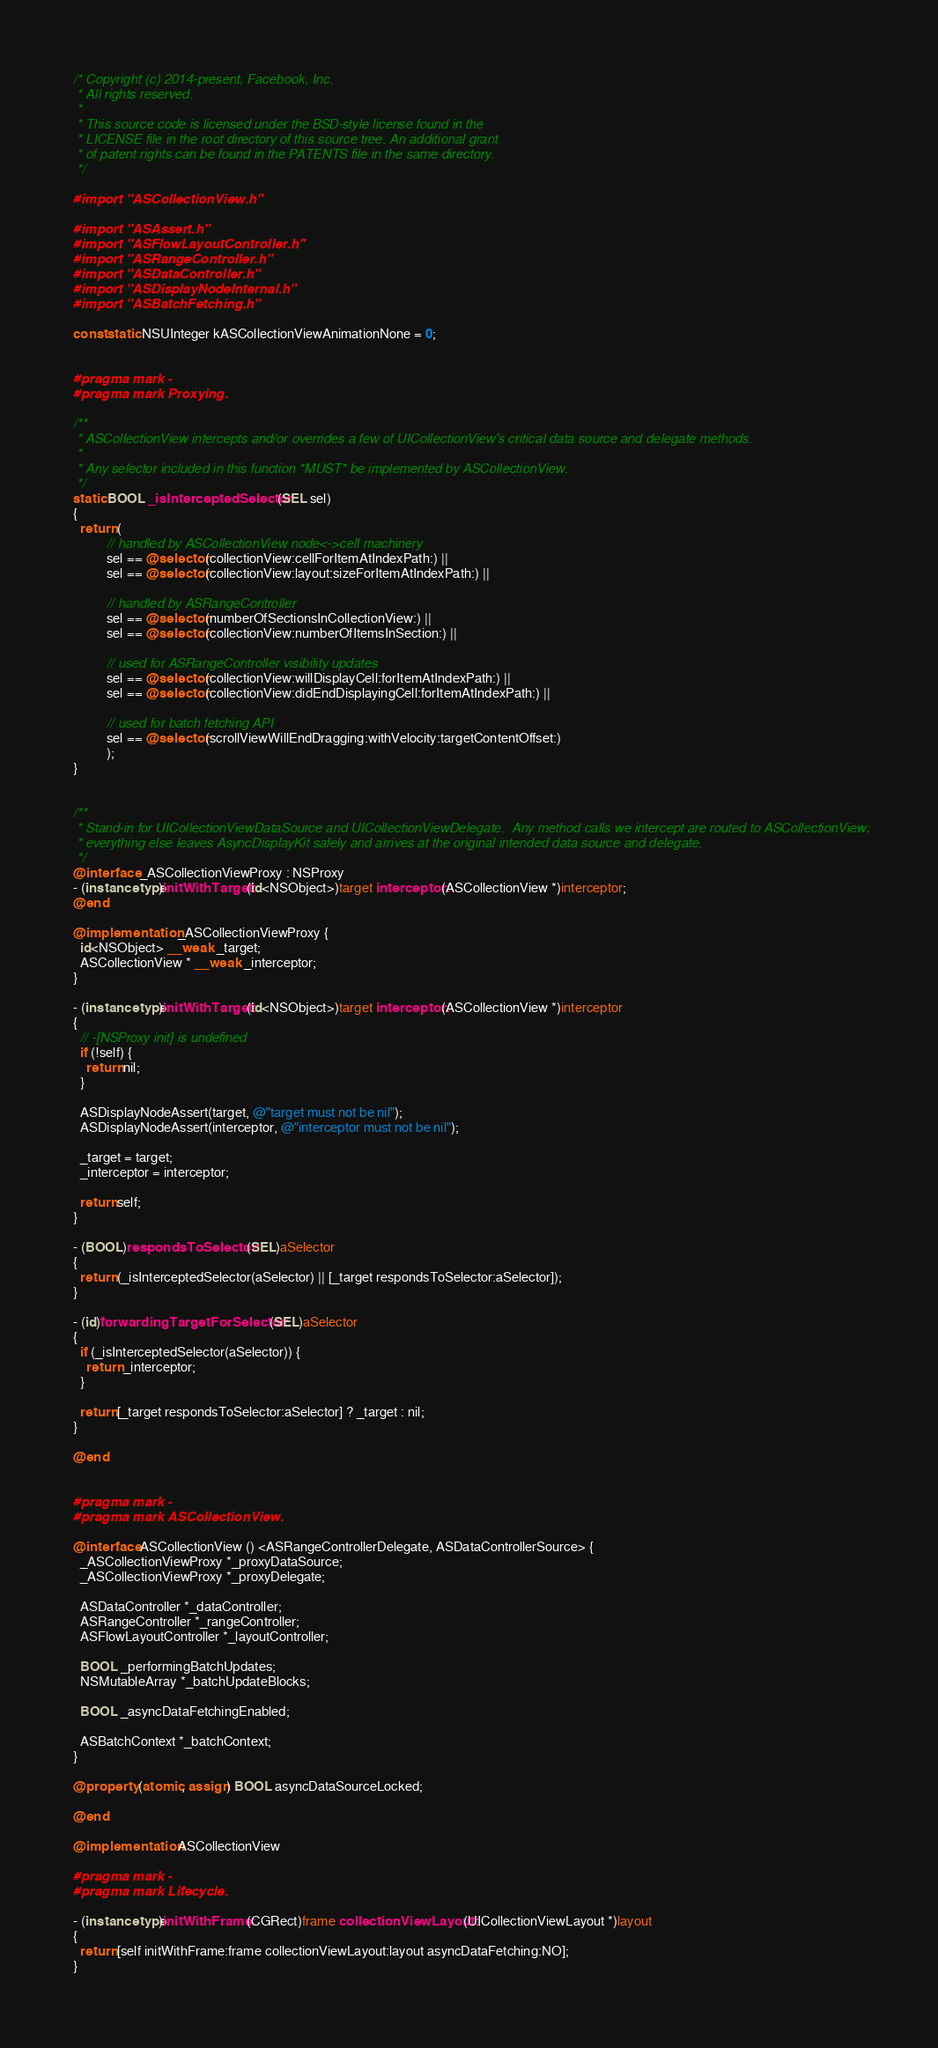Convert code to text. <code><loc_0><loc_0><loc_500><loc_500><_ObjectiveC_>/* Copyright (c) 2014-present, Facebook, Inc.
 * All rights reserved.
 *
 * This source code is licensed under the BSD-style license found in the
 * LICENSE file in the root directory of this source tree. An additional grant
 * of patent rights can be found in the PATENTS file in the same directory.
 */

#import "ASCollectionView.h"

#import "ASAssert.h"
#import "ASFlowLayoutController.h"
#import "ASRangeController.h"
#import "ASDataController.h"
#import "ASDisplayNodeInternal.h"
#import "ASBatchFetching.h"

const static NSUInteger kASCollectionViewAnimationNone = 0;


#pragma mark -
#pragma mark Proxying.

/**
 * ASCollectionView intercepts and/or overrides a few of UICollectionView's critical data source and delegate methods.
 *
 * Any selector included in this function *MUST* be implemented by ASCollectionView.
 */
static BOOL _isInterceptedSelector(SEL sel)
{
  return (          
          // handled by ASCollectionView node<->cell machinery
          sel == @selector(collectionView:cellForItemAtIndexPath:) ||
          sel == @selector(collectionView:layout:sizeForItemAtIndexPath:) ||
          
          // handled by ASRangeController
          sel == @selector(numberOfSectionsInCollectionView:) ||
          sel == @selector(collectionView:numberOfItemsInSection:) ||
          
          // used for ASRangeController visibility updates
          sel == @selector(collectionView:willDisplayCell:forItemAtIndexPath:) ||
          sel == @selector(collectionView:didEndDisplayingCell:forItemAtIndexPath:) ||

          // used for batch fetching API
          sel == @selector(scrollViewWillEndDragging:withVelocity:targetContentOffset:)
          );
}


/**
 * Stand-in for UICollectionViewDataSource and UICollectionViewDelegate.  Any method calls we intercept are routed to ASCollectionView;
 * everything else leaves AsyncDisplayKit safely and arrives at the original intended data source and delegate.
 */
@interface _ASCollectionViewProxy : NSProxy
- (instancetype)initWithTarget:(id<NSObject>)target interceptor:(ASCollectionView *)interceptor;
@end

@implementation _ASCollectionViewProxy {
  id<NSObject> __weak _target;
  ASCollectionView * __weak _interceptor;
}

- (instancetype)initWithTarget:(id<NSObject>)target interceptor:(ASCollectionView *)interceptor
{
  // -[NSProxy init] is undefined
  if (!self) {
    return nil;
  }

  ASDisplayNodeAssert(target, @"target must not be nil");
  ASDisplayNodeAssert(interceptor, @"interceptor must not be nil");
  
  _target = target;
  _interceptor = interceptor;
  
  return self;
}

- (BOOL)respondsToSelector:(SEL)aSelector
{
  return (_isInterceptedSelector(aSelector) || [_target respondsToSelector:aSelector]);
}

- (id)forwardingTargetForSelector:(SEL)aSelector
{
  if (_isInterceptedSelector(aSelector)) {
    return _interceptor;
  }
  
  return [_target respondsToSelector:aSelector] ? _target : nil;
}

@end


#pragma mark -
#pragma mark ASCollectionView.

@interface ASCollectionView () <ASRangeControllerDelegate, ASDataControllerSource> {
  _ASCollectionViewProxy *_proxyDataSource;
  _ASCollectionViewProxy *_proxyDelegate;

  ASDataController *_dataController;
  ASRangeController *_rangeController;
  ASFlowLayoutController *_layoutController;

  BOOL _performingBatchUpdates;
  NSMutableArray *_batchUpdateBlocks;

  BOOL _asyncDataFetchingEnabled;

  ASBatchContext *_batchContext;
}

@property (atomic, assign) BOOL asyncDataSourceLocked;

@end

@implementation ASCollectionView

#pragma mark -
#pragma mark Lifecycle.

- (instancetype)initWithFrame:(CGRect)frame collectionViewLayout:(UICollectionViewLayout *)layout
{
  return [self initWithFrame:frame collectionViewLayout:layout asyncDataFetching:NO];
}
</code> 